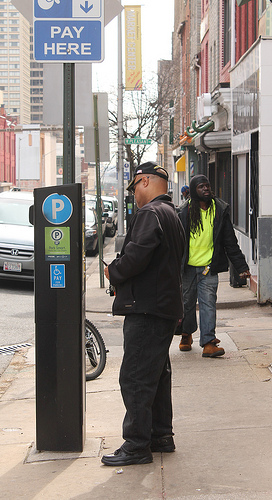<image>
Is the man behind the sign? Yes. From this viewpoint, the man is positioned behind the sign, with the sign partially or fully occluding the man. Where is the bike in relation to the man? Is it behind the man? Yes. From this viewpoint, the bike is positioned behind the man, with the man partially or fully occluding the bike. 